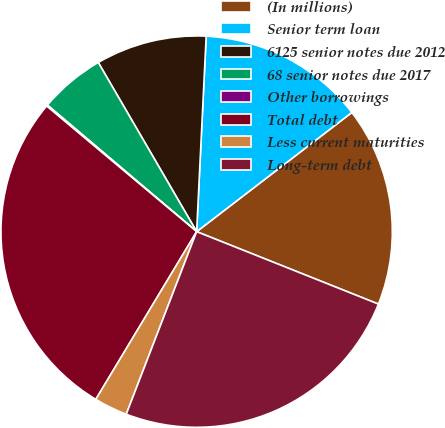Convert chart to OTSL. <chart><loc_0><loc_0><loc_500><loc_500><pie_chart><fcel>(In millions)<fcel>Senior term loan<fcel>6125 senior notes due 2012<fcel>68 senior notes due 2017<fcel>Other borrowings<fcel>Total debt<fcel>Less current maturities<fcel>Long-term debt<nl><fcel>16.46%<fcel>13.8%<fcel>9.16%<fcel>5.42%<fcel>0.1%<fcel>27.48%<fcel>2.76%<fcel>24.82%<nl></chart> 